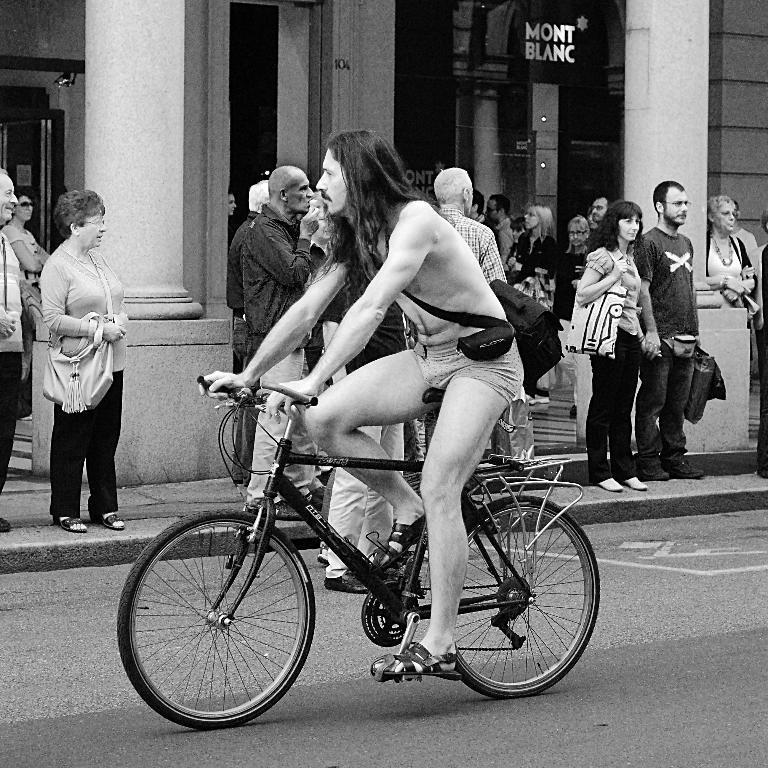Could you give a brief overview of what you see in this image? In this picture we can see a group of people where one man carrying bag and riding bicycle on road and aside to this road people are standing on foot path and in the background we can see pillars, wall, doors. 